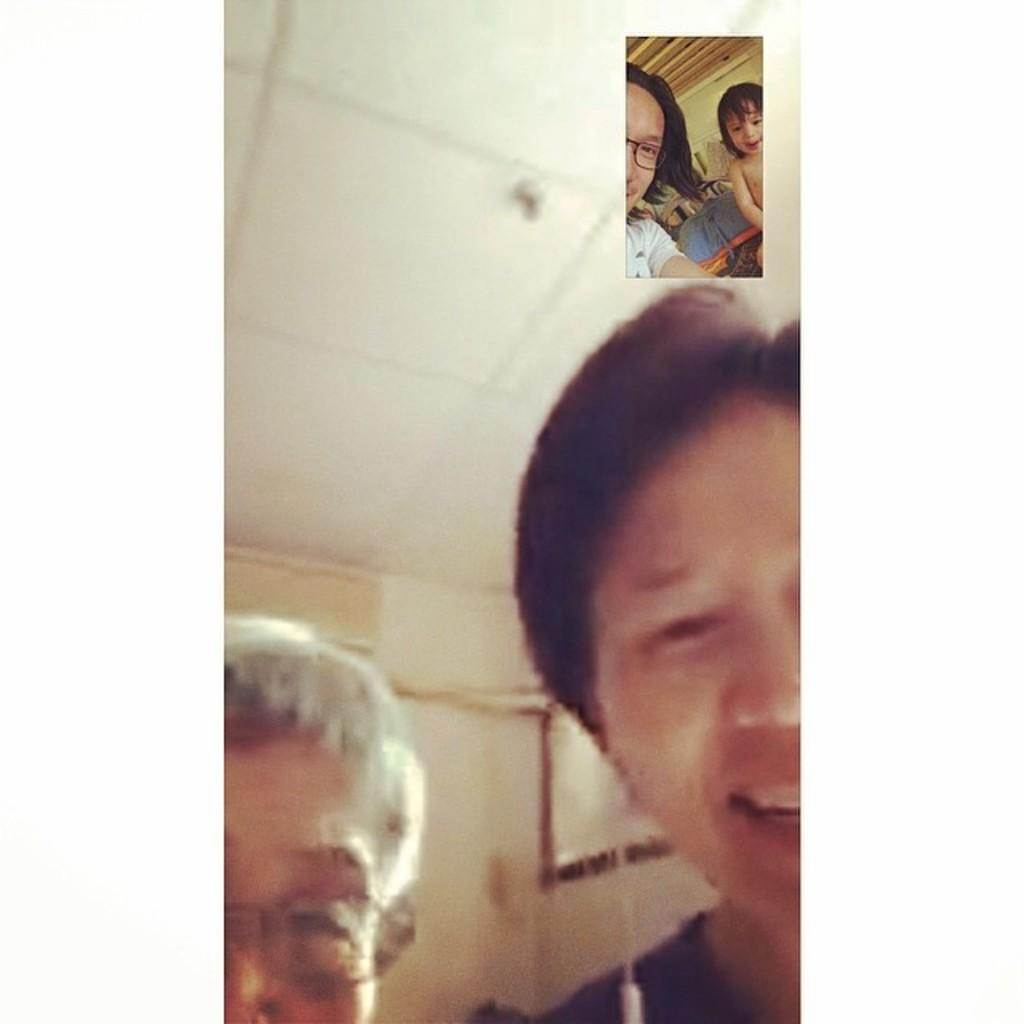What type of image is shown in the screenshot? The image is a screenshot of a video call. Who or what can be seen on the right side of the image? There is a person and a kid visible on the right side of the image. What is visible in the background of the video call? The background of the video call includes a ceiling. What type of silk clothing is the actor wearing in the image? There is no actor or silk clothing present in the image; it is a screenshot of a video call featuring a person and a kid. How many snails can be seen crawling on the ceiling in the image? There are no snails visible in the image; the background of the video call includes a ceiling, but no snails are present. 